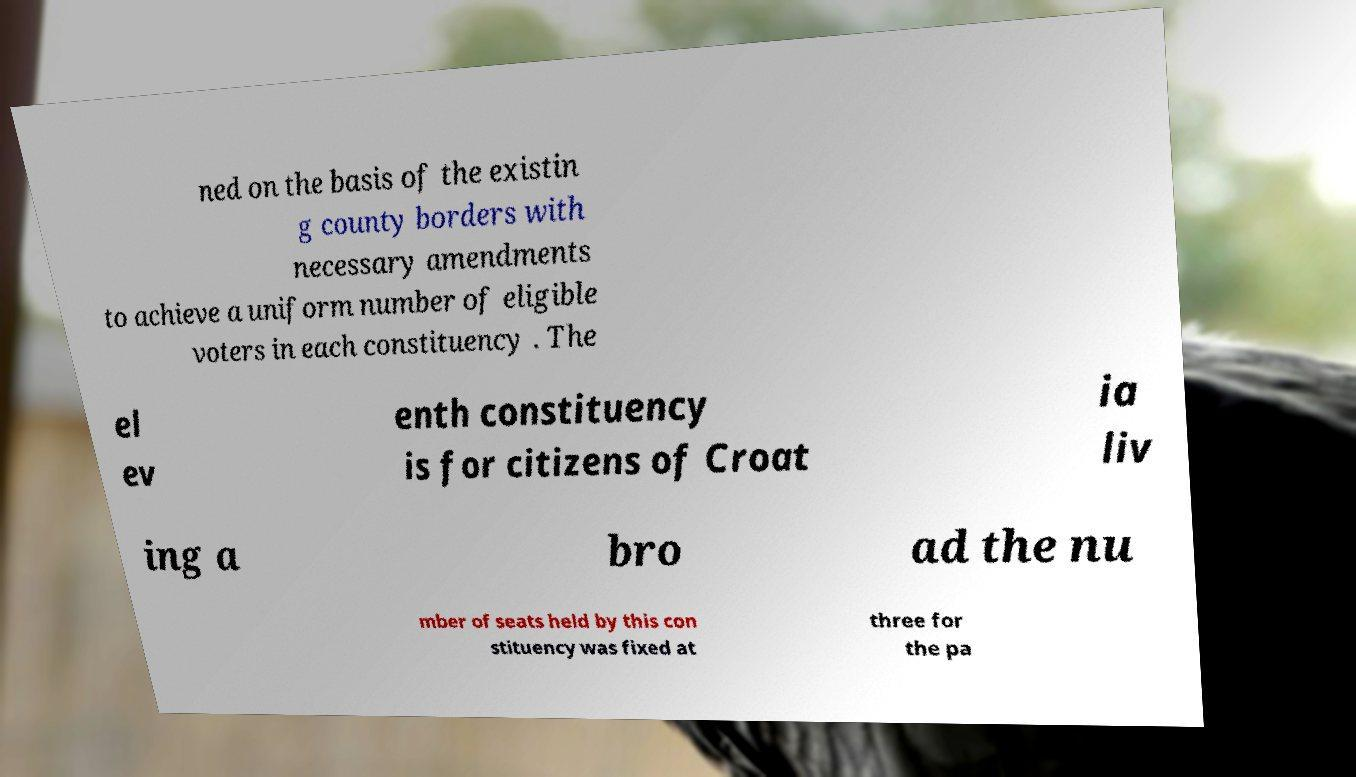Could you assist in decoding the text presented in this image and type it out clearly? ned on the basis of the existin g county borders with necessary amendments to achieve a uniform number of eligible voters in each constituency . The el ev enth constituency is for citizens of Croat ia liv ing a bro ad the nu mber of seats held by this con stituency was fixed at three for the pa 